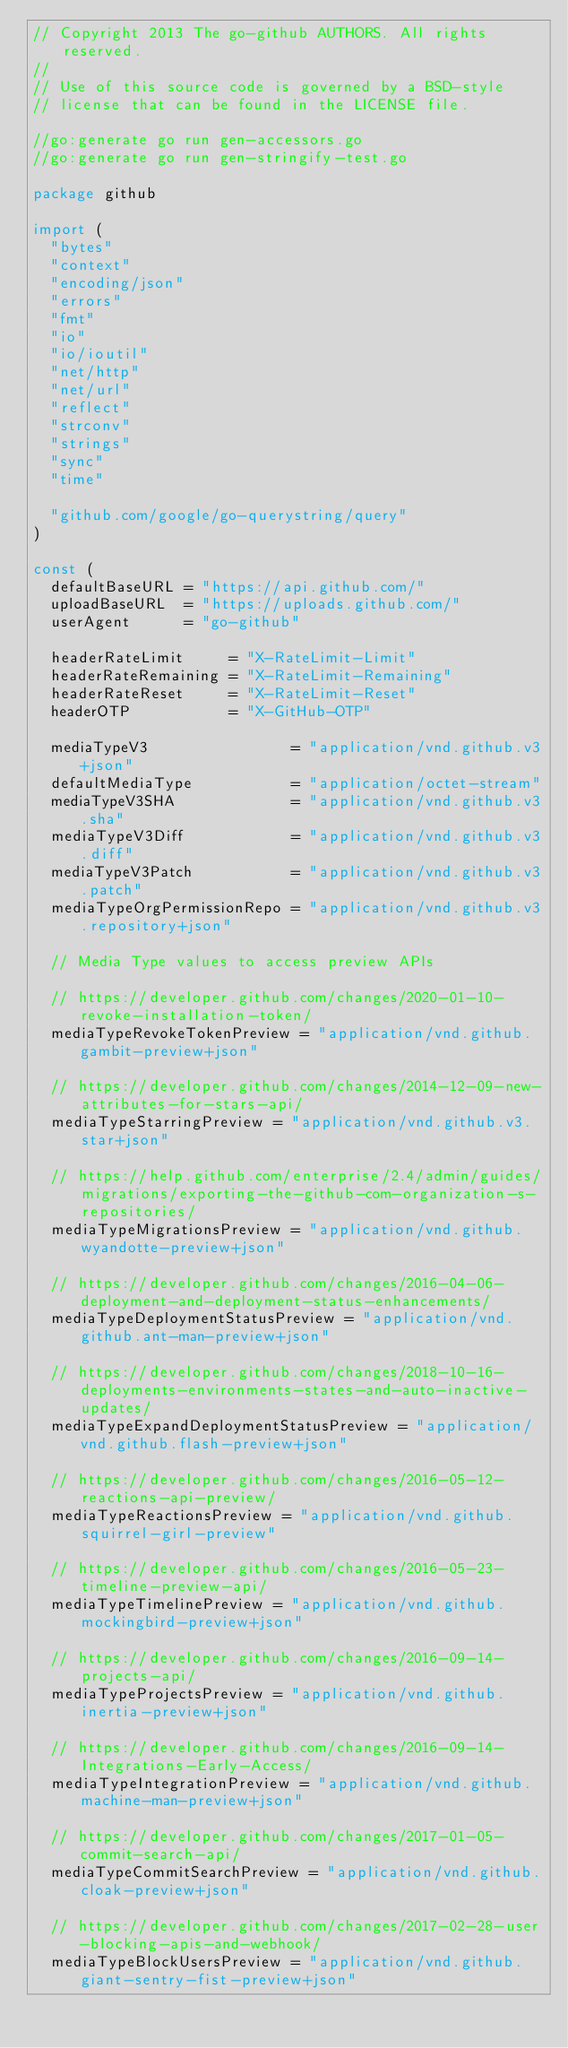Convert code to text. <code><loc_0><loc_0><loc_500><loc_500><_Go_>// Copyright 2013 The go-github AUTHORS. All rights reserved.
//
// Use of this source code is governed by a BSD-style
// license that can be found in the LICENSE file.

//go:generate go run gen-accessors.go
//go:generate go run gen-stringify-test.go

package github

import (
	"bytes"
	"context"
	"encoding/json"
	"errors"
	"fmt"
	"io"
	"io/ioutil"
	"net/http"
	"net/url"
	"reflect"
	"strconv"
	"strings"
	"sync"
	"time"

	"github.com/google/go-querystring/query"
)

const (
	defaultBaseURL = "https://api.github.com/"
	uploadBaseURL  = "https://uploads.github.com/"
	userAgent      = "go-github"

	headerRateLimit     = "X-RateLimit-Limit"
	headerRateRemaining = "X-RateLimit-Remaining"
	headerRateReset     = "X-RateLimit-Reset"
	headerOTP           = "X-GitHub-OTP"

	mediaTypeV3                = "application/vnd.github.v3+json"
	defaultMediaType           = "application/octet-stream"
	mediaTypeV3SHA             = "application/vnd.github.v3.sha"
	mediaTypeV3Diff            = "application/vnd.github.v3.diff"
	mediaTypeV3Patch           = "application/vnd.github.v3.patch"
	mediaTypeOrgPermissionRepo = "application/vnd.github.v3.repository+json"

	// Media Type values to access preview APIs

	// https://developer.github.com/changes/2020-01-10-revoke-installation-token/
	mediaTypeRevokeTokenPreview = "application/vnd.github.gambit-preview+json"

	// https://developer.github.com/changes/2014-12-09-new-attributes-for-stars-api/
	mediaTypeStarringPreview = "application/vnd.github.v3.star+json"

	// https://help.github.com/enterprise/2.4/admin/guides/migrations/exporting-the-github-com-organization-s-repositories/
	mediaTypeMigrationsPreview = "application/vnd.github.wyandotte-preview+json"

	// https://developer.github.com/changes/2016-04-06-deployment-and-deployment-status-enhancements/
	mediaTypeDeploymentStatusPreview = "application/vnd.github.ant-man-preview+json"

	// https://developer.github.com/changes/2018-10-16-deployments-environments-states-and-auto-inactive-updates/
	mediaTypeExpandDeploymentStatusPreview = "application/vnd.github.flash-preview+json"

	// https://developer.github.com/changes/2016-05-12-reactions-api-preview/
	mediaTypeReactionsPreview = "application/vnd.github.squirrel-girl-preview"

	// https://developer.github.com/changes/2016-05-23-timeline-preview-api/
	mediaTypeTimelinePreview = "application/vnd.github.mockingbird-preview+json"

	// https://developer.github.com/changes/2016-09-14-projects-api/
	mediaTypeProjectsPreview = "application/vnd.github.inertia-preview+json"

	// https://developer.github.com/changes/2016-09-14-Integrations-Early-Access/
	mediaTypeIntegrationPreview = "application/vnd.github.machine-man-preview+json"

	// https://developer.github.com/changes/2017-01-05-commit-search-api/
	mediaTypeCommitSearchPreview = "application/vnd.github.cloak-preview+json"

	// https://developer.github.com/changes/2017-02-28-user-blocking-apis-and-webhook/
	mediaTypeBlockUsersPreview = "application/vnd.github.giant-sentry-fist-preview+json"
</code> 